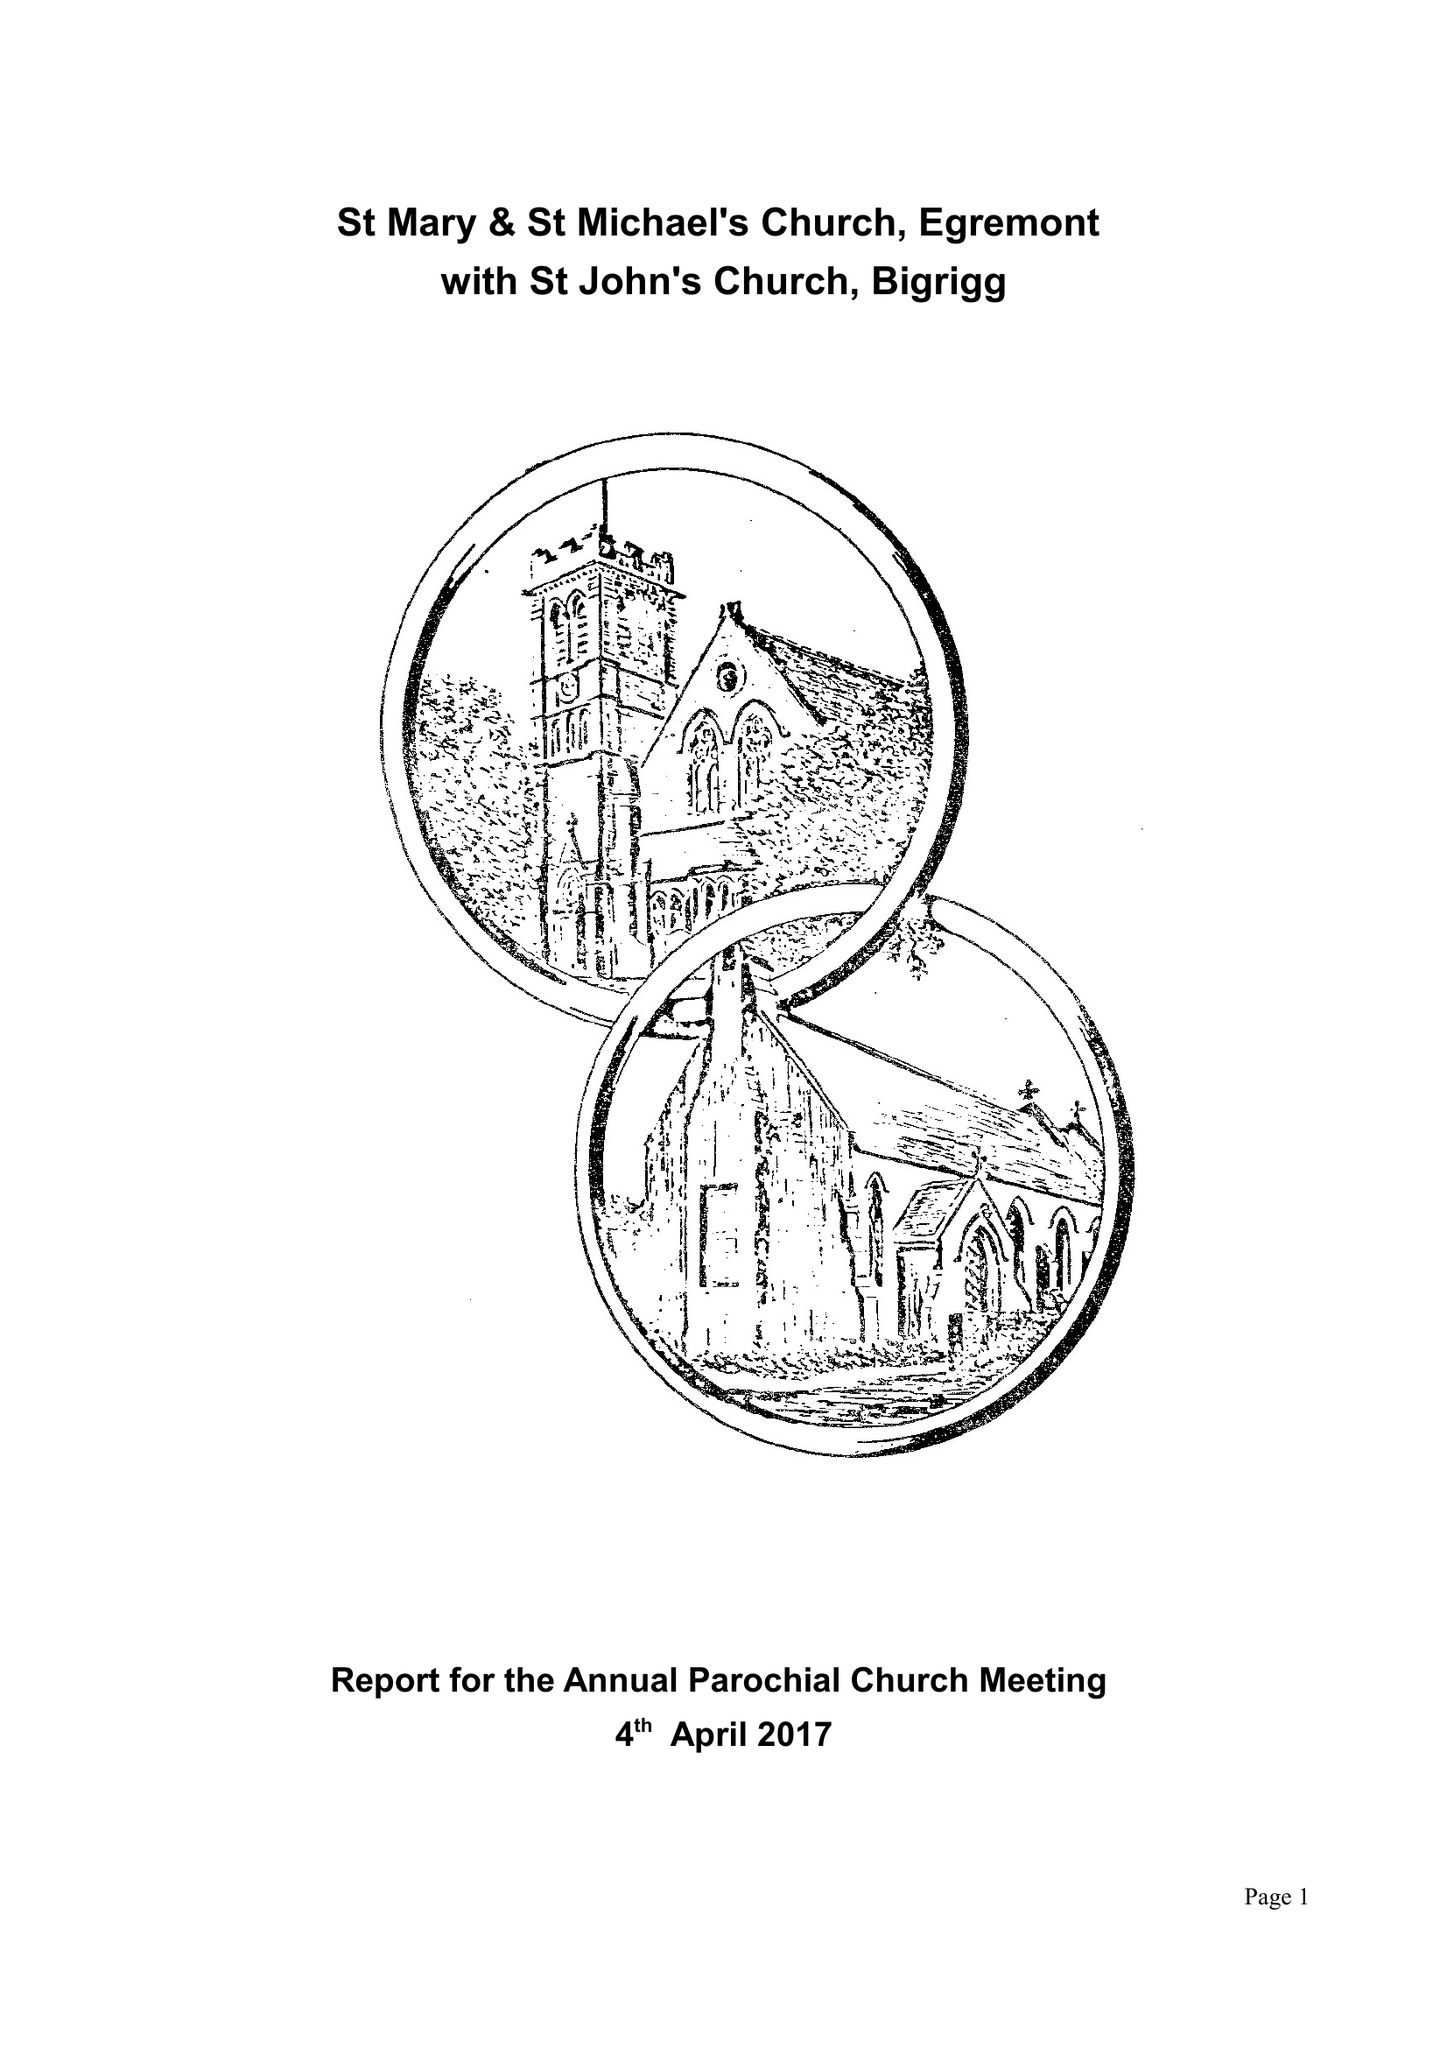What is the value for the charity_name?
Answer the question using a single word or phrase. The Parochial Church Council Of The Ecclesiastical Parish Of St Mary and St Michael's, Egremont 